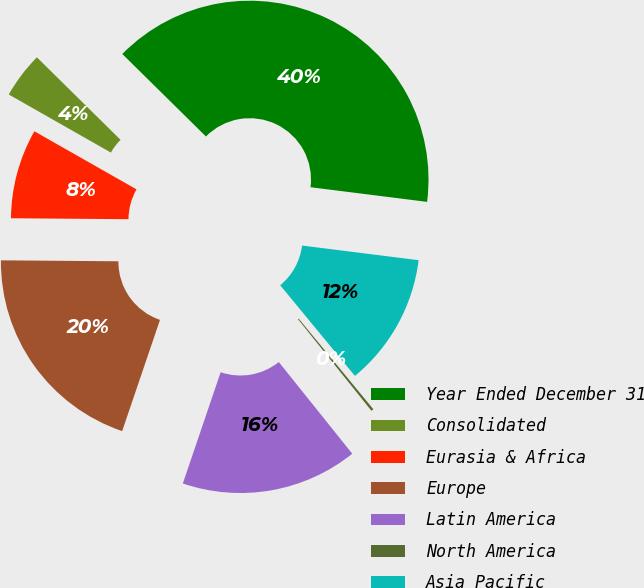<chart> <loc_0><loc_0><loc_500><loc_500><pie_chart><fcel>Year Ended December 31<fcel>Consolidated<fcel>Eurasia & Africa<fcel>Europe<fcel>Latin America<fcel>North America<fcel>Asia Pacific<nl><fcel>39.6%<fcel>4.16%<fcel>8.1%<fcel>19.91%<fcel>15.97%<fcel>0.22%<fcel>12.04%<nl></chart> 